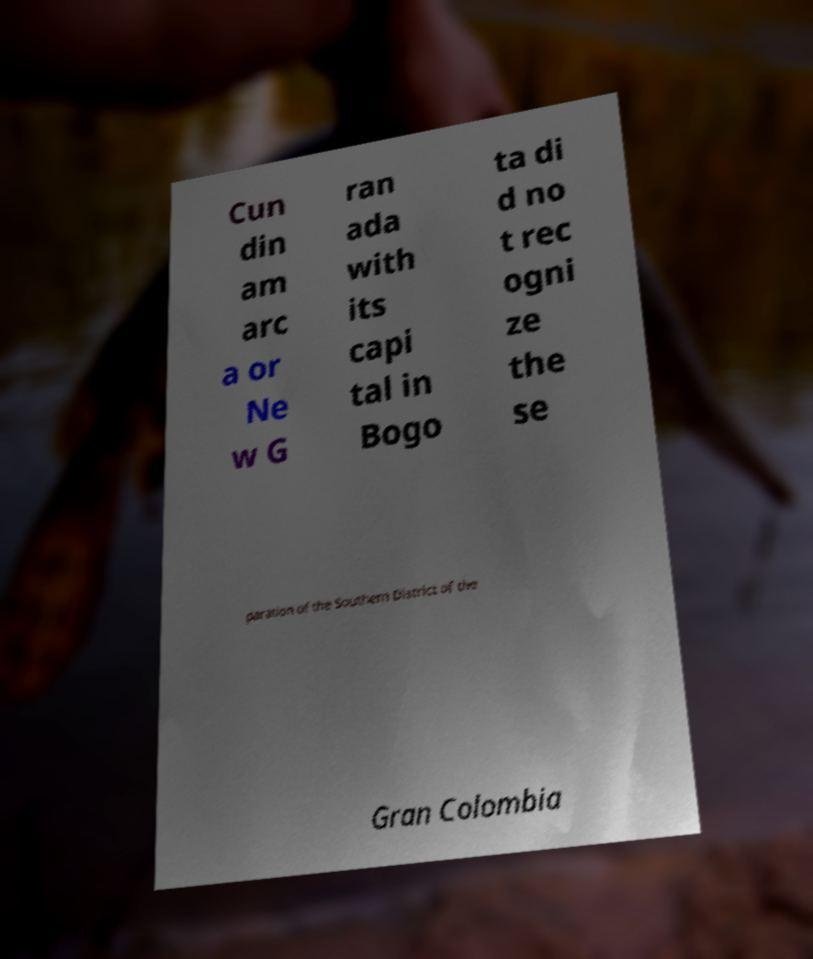I need the written content from this picture converted into text. Can you do that? Cun din am arc a or Ne w G ran ada with its capi tal in Bogo ta di d no t rec ogni ze the se paration of the Southern District of the Gran Colombia 